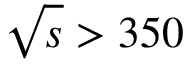Convert formula to latex. <formula><loc_0><loc_0><loc_500><loc_500>\sqrt { s } > 3 5 0</formula> 